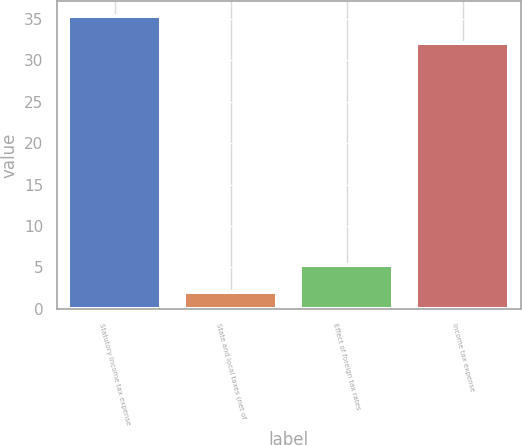Convert chart. <chart><loc_0><loc_0><loc_500><loc_500><bar_chart><fcel>Statutory income tax expense<fcel>State and local taxes (net of<fcel>Effect of foreign tax rates<fcel>Income tax expense<nl><fcel>35.3<fcel>2<fcel>5.3<fcel>32<nl></chart> 